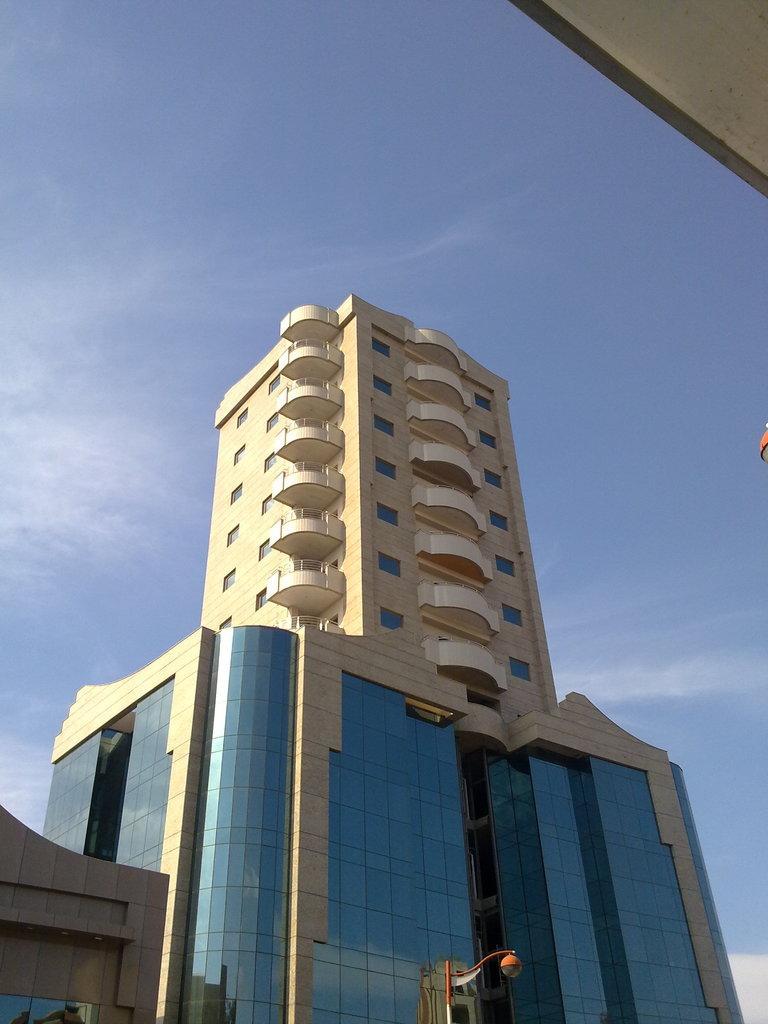Describe this image in one or two sentences. In this image there are buildings, we can see windows, there is a pole with light. And there is sky at the top. 